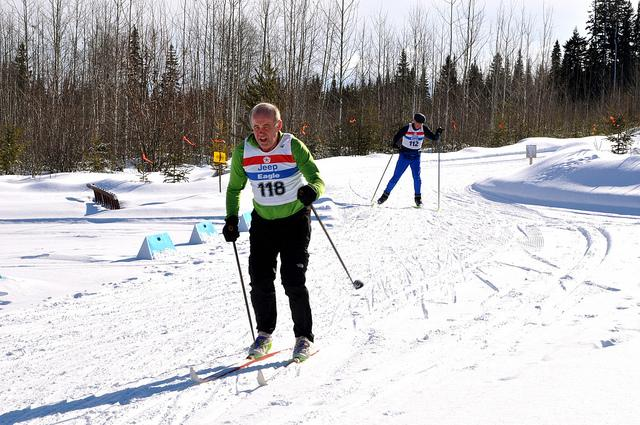What number is on the man in the green shirt's jersey? Please explain your reasoning. 118. The number is visible and clear on his jersey. 